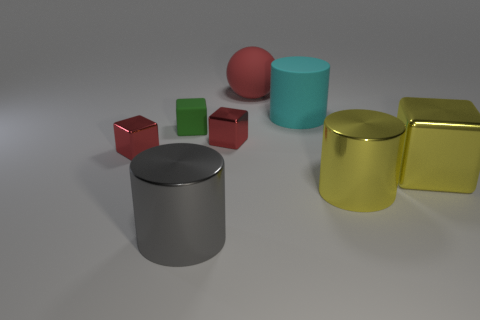Subtract all small green blocks. How many blocks are left? 3 Subtract all yellow cubes. How many cubes are left? 3 Subtract 1 cylinders. How many cylinders are left? 2 Subtract all purple cubes. Subtract all cyan balls. How many cubes are left? 4 Add 1 big yellow metal cylinders. How many objects exist? 9 Subtract 0 gray spheres. How many objects are left? 8 Subtract all balls. How many objects are left? 7 Subtract all small purple rubber things. Subtract all red cubes. How many objects are left? 6 Add 8 small red things. How many small red things are left? 10 Add 6 large gray objects. How many large gray objects exist? 7 